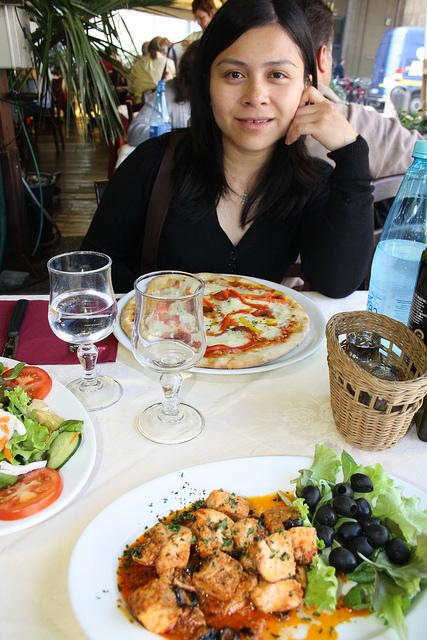What is the woman in black about to eat?

Choices:
A) hamburger
B) pizza
C) egg
D) hot dog pizza 